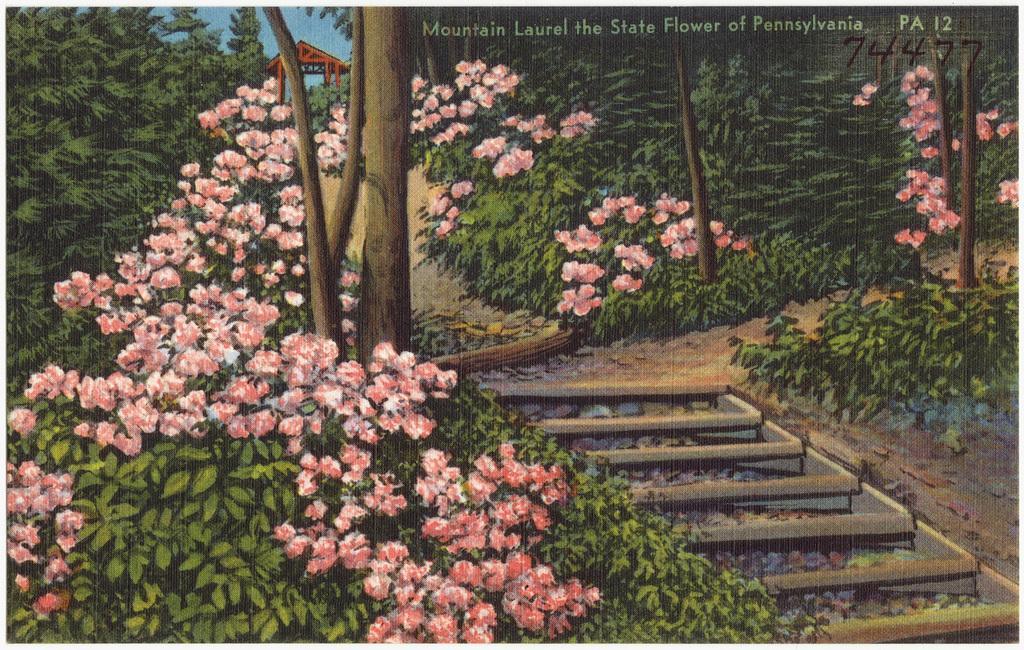In one or two sentences, can you explain what this image depicts? This is an animated image. In this image, we can see plants with some flowers and the flowers are in pink color, we can also see some trees. In the background, we can see a hut. On the top, we can see a sky, at the bottom, we can also see a bridge. 